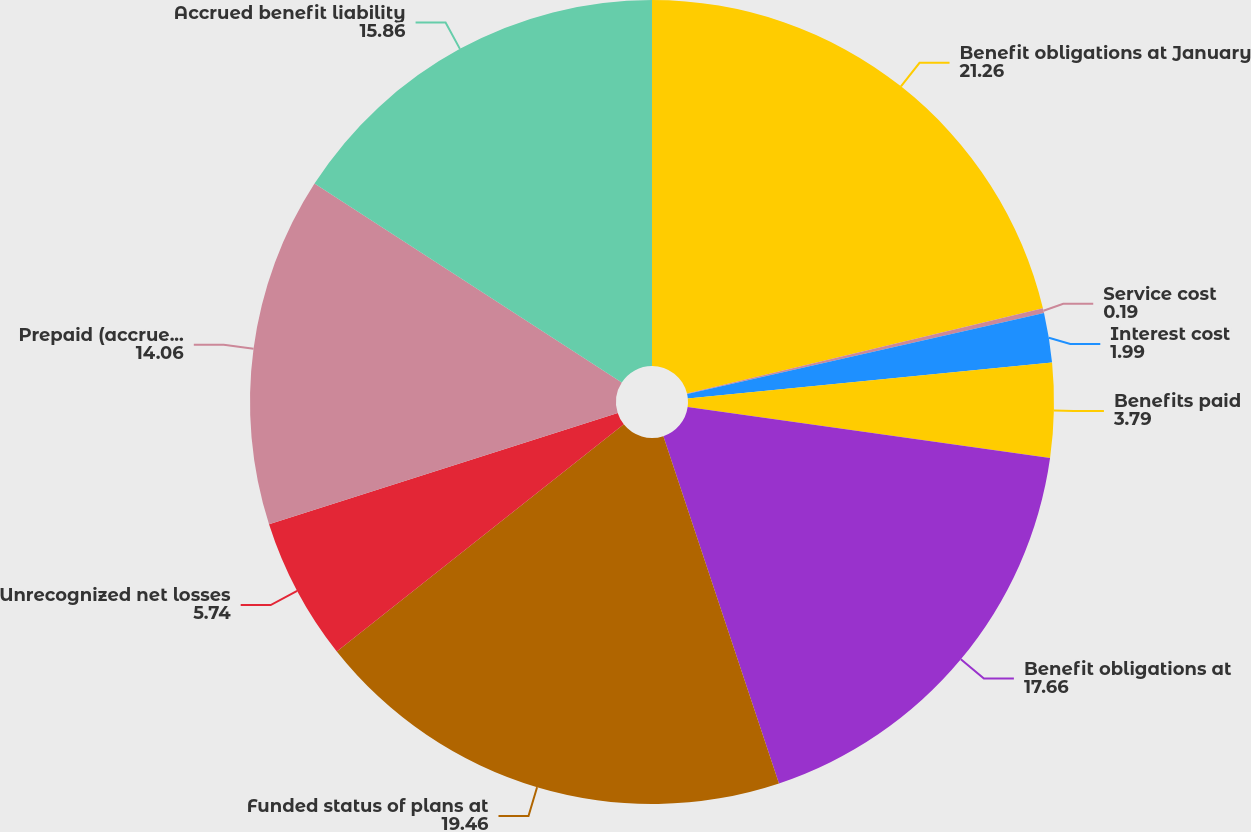Convert chart. <chart><loc_0><loc_0><loc_500><loc_500><pie_chart><fcel>Benefit obligations at January<fcel>Service cost<fcel>Interest cost<fcel>Benefits paid<fcel>Benefit obligations at<fcel>Funded status of plans at<fcel>Unrecognized net losses<fcel>Prepaid (accrued) benefit cost<fcel>Accrued benefit liability<nl><fcel>21.26%<fcel>0.19%<fcel>1.99%<fcel>3.79%<fcel>17.66%<fcel>19.46%<fcel>5.74%<fcel>14.06%<fcel>15.86%<nl></chart> 